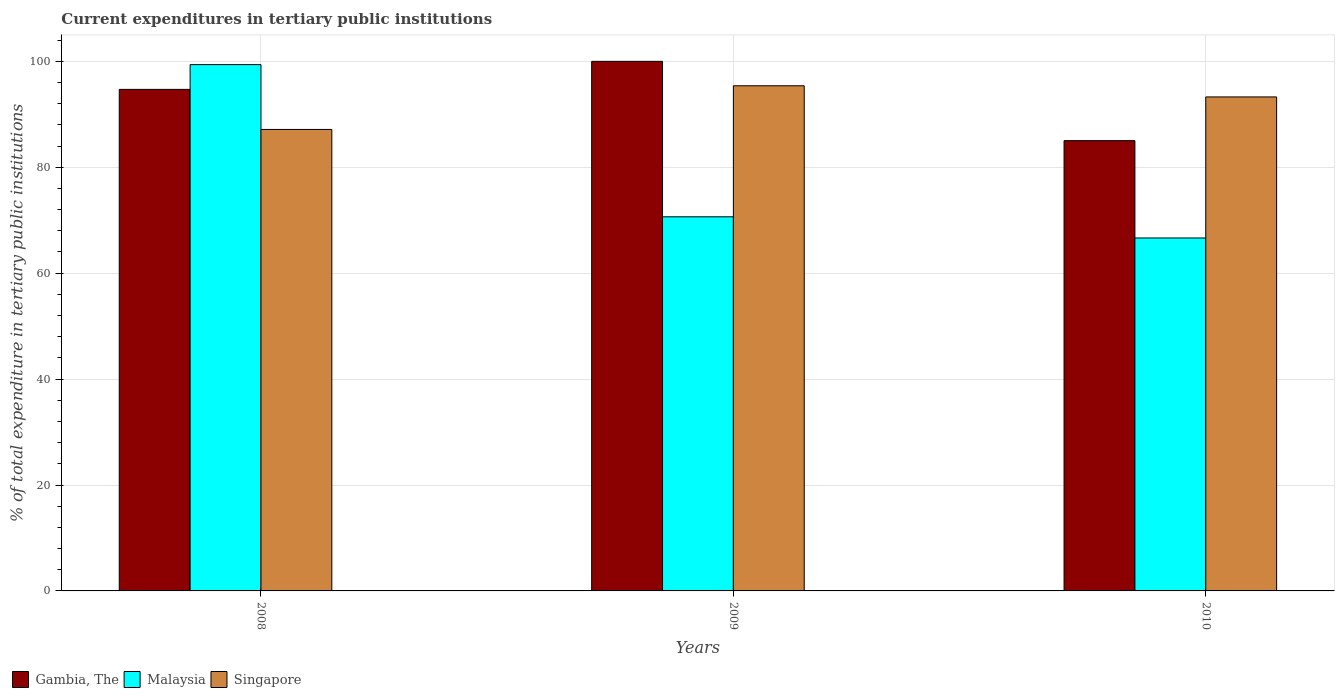How many groups of bars are there?
Offer a terse response. 3. Are the number of bars per tick equal to the number of legend labels?
Make the answer very short. Yes. What is the current expenditures in tertiary public institutions in Singapore in 2008?
Make the answer very short. 87.14. Across all years, what is the maximum current expenditures in tertiary public institutions in Singapore?
Offer a very short reply. 95.39. Across all years, what is the minimum current expenditures in tertiary public institutions in Malaysia?
Make the answer very short. 66.65. In which year was the current expenditures in tertiary public institutions in Gambia, The minimum?
Offer a terse response. 2010. What is the total current expenditures in tertiary public institutions in Malaysia in the graph?
Keep it short and to the point. 236.68. What is the difference between the current expenditures in tertiary public institutions in Gambia, The in 2008 and that in 2009?
Provide a succinct answer. -5.29. What is the difference between the current expenditures in tertiary public institutions in Malaysia in 2008 and the current expenditures in tertiary public institutions in Singapore in 2010?
Provide a succinct answer. 6.1. What is the average current expenditures in tertiary public institutions in Gambia, The per year?
Your answer should be compact. 93.24. In the year 2009, what is the difference between the current expenditures in tertiary public institutions in Malaysia and current expenditures in tertiary public institutions in Singapore?
Provide a succinct answer. -24.74. What is the ratio of the current expenditures in tertiary public institutions in Gambia, The in 2008 to that in 2010?
Make the answer very short. 1.11. Is the current expenditures in tertiary public institutions in Singapore in 2008 less than that in 2010?
Ensure brevity in your answer.  Yes. Is the difference between the current expenditures in tertiary public institutions in Malaysia in 2008 and 2009 greater than the difference between the current expenditures in tertiary public institutions in Singapore in 2008 and 2009?
Provide a succinct answer. Yes. What is the difference between the highest and the second highest current expenditures in tertiary public institutions in Malaysia?
Offer a very short reply. 28.74. What is the difference between the highest and the lowest current expenditures in tertiary public institutions in Malaysia?
Your answer should be compact. 32.74. What does the 1st bar from the left in 2010 represents?
Offer a terse response. Gambia, The. What does the 1st bar from the right in 2008 represents?
Ensure brevity in your answer.  Singapore. How many years are there in the graph?
Your answer should be very brief. 3. Does the graph contain grids?
Give a very brief answer. Yes. How many legend labels are there?
Keep it short and to the point. 3. How are the legend labels stacked?
Your response must be concise. Horizontal. What is the title of the graph?
Your response must be concise. Current expenditures in tertiary public institutions. Does "Mozambique" appear as one of the legend labels in the graph?
Ensure brevity in your answer.  No. What is the label or title of the Y-axis?
Your answer should be very brief. % of total expenditure in tertiary public institutions. What is the % of total expenditure in tertiary public institutions in Gambia, The in 2008?
Keep it short and to the point. 94.71. What is the % of total expenditure in tertiary public institutions in Malaysia in 2008?
Give a very brief answer. 99.38. What is the % of total expenditure in tertiary public institutions in Singapore in 2008?
Your response must be concise. 87.14. What is the % of total expenditure in tertiary public institutions of Malaysia in 2009?
Offer a very short reply. 70.64. What is the % of total expenditure in tertiary public institutions of Singapore in 2009?
Give a very brief answer. 95.39. What is the % of total expenditure in tertiary public institutions in Gambia, The in 2010?
Keep it short and to the point. 85.03. What is the % of total expenditure in tertiary public institutions of Malaysia in 2010?
Your answer should be compact. 66.65. What is the % of total expenditure in tertiary public institutions in Singapore in 2010?
Keep it short and to the point. 93.28. Across all years, what is the maximum % of total expenditure in tertiary public institutions in Malaysia?
Your answer should be very brief. 99.38. Across all years, what is the maximum % of total expenditure in tertiary public institutions of Singapore?
Keep it short and to the point. 95.39. Across all years, what is the minimum % of total expenditure in tertiary public institutions of Gambia, The?
Provide a short and direct response. 85.03. Across all years, what is the minimum % of total expenditure in tertiary public institutions of Malaysia?
Your response must be concise. 66.65. Across all years, what is the minimum % of total expenditure in tertiary public institutions in Singapore?
Your answer should be compact. 87.14. What is the total % of total expenditure in tertiary public institutions in Gambia, The in the graph?
Ensure brevity in your answer.  279.73. What is the total % of total expenditure in tertiary public institutions in Malaysia in the graph?
Provide a short and direct response. 236.68. What is the total % of total expenditure in tertiary public institutions in Singapore in the graph?
Your answer should be very brief. 275.81. What is the difference between the % of total expenditure in tertiary public institutions in Gambia, The in 2008 and that in 2009?
Your response must be concise. -5.29. What is the difference between the % of total expenditure in tertiary public institutions of Malaysia in 2008 and that in 2009?
Ensure brevity in your answer.  28.74. What is the difference between the % of total expenditure in tertiary public institutions of Singapore in 2008 and that in 2009?
Give a very brief answer. -8.25. What is the difference between the % of total expenditure in tertiary public institutions of Gambia, The in 2008 and that in 2010?
Your answer should be compact. 9.68. What is the difference between the % of total expenditure in tertiary public institutions of Malaysia in 2008 and that in 2010?
Give a very brief answer. 32.74. What is the difference between the % of total expenditure in tertiary public institutions of Singapore in 2008 and that in 2010?
Provide a short and direct response. -6.14. What is the difference between the % of total expenditure in tertiary public institutions of Gambia, The in 2009 and that in 2010?
Your answer should be compact. 14.97. What is the difference between the % of total expenditure in tertiary public institutions in Malaysia in 2009 and that in 2010?
Give a very brief answer. 4. What is the difference between the % of total expenditure in tertiary public institutions of Singapore in 2009 and that in 2010?
Make the answer very short. 2.11. What is the difference between the % of total expenditure in tertiary public institutions of Gambia, The in 2008 and the % of total expenditure in tertiary public institutions of Malaysia in 2009?
Offer a very short reply. 24.06. What is the difference between the % of total expenditure in tertiary public institutions in Gambia, The in 2008 and the % of total expenditure in tertiary public institutions in Singapore in 2009?
Provide a short and direct response. -0.68. What is the difference between the % of total expenditure in tertiary public institutions of Malaysia in 2008 and the % of total expenditure in tertiary public institutions of Singapore in 2009?
Give a very brief answer. 4. What is the difference between the % of total expenditure in tertiary public institutions in Gambia, The in 2008 and the % of total expenditure in tertiary public institutions in Malaysia in 2010?
Your answer should be very brief. 28.06. What is the difference between the % of total expenditure in tertiary public institutions in Gambia, The in 2008 and the % of total expenditure in tertiary public institutions in Singapore in 2010?
Ensure brevity in your answer.  1.43. What is the difference between the % of total expenditure in tertiary public institutions of Malaysia in 2008 and the % of total expenditure in tertiary public institutions of Singapore in 2010?
Make the answer very short. 6.1. What is the difference between the % of total expenditure in tertiary public institutions of Gambia, The in 2009 and the % of total expenditure in tertiary public institutions of Malaysia in 2010?
Your answer should be compact. 33.35. What is the difference between the % of total expenditure in tertiary public institutions in Gambia, The in 2009 and the % of total expenditure in tertiary public institutions in Singapore in 2010?
Make the answer very short. 6.72. What is the difference between the % of total expenditure in tertiary public institutions in Malaysia in 2009 and the % of total expenditure in tertiary public institutions in Singapore in 2010?
Your answer should be very brief. -22.64. What is the average % of total expenditure in tertiary public institutions in Gambia, The per year?
Ensure brevity in your answer.  93.24. What is the average % of total expenditure in tertiary public institutions of Malaysia per year?
Your answer should be compact. 78.89. What is the average % of total expenditure in tertiary public institutions of Singapore per year?
Your answer should be very brief. 91.94. In the year 2008, what is the difference between the % of total expenditure in tertiary public institutions of Gambia, The and % of total expenditure in tertiary public institutions of Malaysia?
Provide a succinct answer. -4.68. In the year 2008, what is the difference between the % of total expenditure in tertiary public institutions in Gambia, The and % of total expenditure in tertiary public institutions in Singapore?
Provide a short and direct response. 7.57. In the year 2008, what is the difference between the % of total expenditure in tertiary public institutions in Malaysia and % of total expenditure in tertiary public institutions in Singapore?
Keep it short and to the point. 12.24. In the year 2009, what is the difference between the % of total expenditure in tertiary public institutions in Gambia, The and % of total expenditure in tertiary public institutions in Malaysia?
Your answer should be compact. 29.36. In the year 2009, what is the difference between the % of total expenditure in tertiary public institutions in Gambia, The and % of total expenditure in tertiary public institutions in Singapore?
Your answer should be compact. 4.61. In the year 2009, what is the difference between the % of total expenditure in tertiary public institutions of Malaysia and % of total expenditure in tertiary public institutions of Singapore?
Your answer should be very brief. -24.74. In the year 2010, what is the difference between the % of total expenditure in tertiary public institutions in Gambia, The and % of total expenditure in tertiary public institutions in Malaysia?
Your answer should be compact. 18.38. In the year 2010, what is the difference between the % of total expenditure in tertiary public institutions of Gambia, The and % of total expenditure in tertiary public institutions of Singapore?
Make the answer very short. -8.25. In the year 2010, what is the difference between the % of total expenditure in tertiary public institutions in Malaysia and % of total expenditure in tertiary public institutions in Singapore?
Give a very brief answer. -26.63. What is the ratio of the % of total expenditure in tertiary public institutions in Gambia, The in 2008 to that in 2009?
Your answer should be very brief. 0.95. What is the ratio of the % of total expenditure in tertiary public institutions of Malaysia in 2008 to that in 2009?
Your answer should be very brief. 1.41. What is the ratio of the % of total expenditure in tertiary public institutions in Singapore in 2008 to that in 2009?
Ensure brevity in your answer.  0.91. What is the ratio of the % of total expenditure in tertiary public institutions of Gambia, The in 2008 to that in 2010?
Offer a very short reply. 1.11. What is the ratio of the % of total expenditure in tertiary public institutions in Malaysia in 2008 to that in 2010?
Provide a succinct answer. 1.49. What is the ratio of the % of total expenditure in tertiary public institutions in Singapore in 2008 to that in 2010?
Provide a succinct answer. 0.93. What is the ratio of the % of total expenditure in tertiary public institutions of Gambia, The in 2009 to that in 2010?
Offer a very short reply. 1.18. What is the ratio of the % of total expenditure in tertiary public institutions of Malaysia in 2009 to that in 2010?
Your response must be concise. 1.06. What is the ratio of the % of total expenditure in tertiary public institutions of Singapore in 2009 to that in 2010?
Your response must be concise. 1.02. What is the difference between the highest and the second highest % of total expenditure in tertiary public institutions of Gambia, The?
Your response must be concise. 5.29. What is the difference between the highest and the second highest % of total expenditure in tertiary public institutions in Malaysia?
Your response must be concise. 28.74. What is the difference between the highest and the second highest % of total expenditure in tertiary public institutions of Singapore?
Provide a succinct answer. 2.11. What is the difference between the highest and the lowest % of total expenditure in tertiary public institutions in Gambia, The?
Keep it short and to the point. 14.97. What is the difference between the highest and the lowest % of total expenditure in tertiary public institutions in Malaysia?
Your answer should be very brief. 32.74. What is the difference between the highest and the lowest % of total expenditure in tertiary public institutions in Singapore?
Make the answer very short. 8.25. 